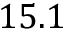<formula> <loc_0><loc_0><loc_500><loc_500>1 5 . 1</formula> 